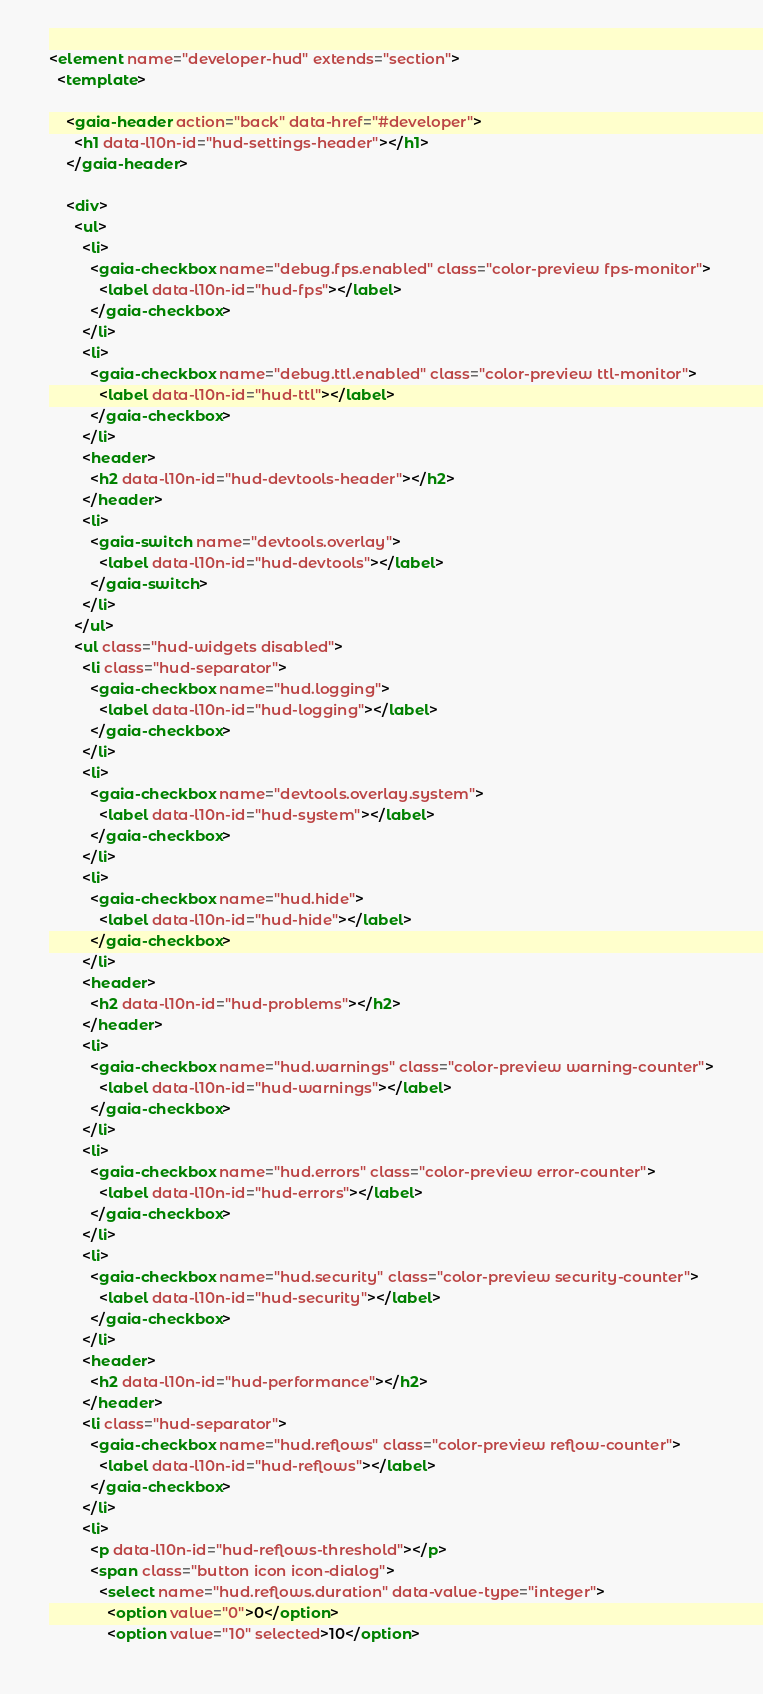<code> <loc_0><loc_0><loc_500><loc_500><_HTML_><element name="developer-hud" extends="section">
  <template>

    <gaia-header action="back" data-href="#developer">
      <h1 data-l10n-id="hud-settings-header"></h1>
    </gaia-header>

    <div>
      <ul>
        <li>
          <gaia-checkbox name="debug.fps.enabled" class="color-preview fps-monitor">
            <label data-l10n-id="hud-fps"></label>
          </gaia-checkbox>
        </li>
        <li>
          <gaia-checkbox name="debug.ttl.enabled" class="color-preview ttl-monitor">
            <label data-l10n-id="hud-ttl"></label>
          </gaia-checkbox>
        </li>
        <header>
          <h2 data-l10n-id="hud-devtools-header"></h2>
        </header>
        <li>
          <gaia-switch name="devtools.overlay">
            <label data-l10n-id="hud-devtools"></label>
          </gaia-switch>
        </li>
      </ul>
      <ul class="hud-widgets disabled">
        <li class="hud-separator">
          <gaia-checkbox name="hud.logging">
            <label data-l10n-id="hud-logging"></label>
          </gaia-checkbox>
        </li>
        <li>
          <gaia-checkbox name="devtools.overlay.system">
            <label data-l10n-id="hud-system"></label>
          </gaia-checkbox>
        </li>
        <li>
          <gaia-checkbox name="hud.hide">
            <label data-l10n-id="hud-hide"></label>
          </gaia-checkbox>
        </li>
        <header>
          <h2 data-l10n-id="hud-problems"></h2>
        </header>
        <li>
          <gaia-checkbox name="hud.warnings" class="color-preview warning-counter">
            <label data-l10n-id="hud-warnings"></label>
          </gaia-checkbox>
        </li>
        <li>
          <gaia-checkbox name="hud.errors" class="color-preview error-counter">
            <label data-l10n-id="hud-errors"></label>
          </gaia-checkbox>
        </li>
        <li>
          <gaia-checkbox name="hud.security" class="color-preview security-counter">
            <label data-l10n-id="hud-security"></label>
          </gaia-checkbox>
        </li>
        <header>
          <h2 data-l10n-id="hud-performance"></h2>
        </header>
        <li class="hud-separator">
          <gaia-checkbox name="hud.reflows" class="color-preview reflow-counter">
            <label data-l10n-id="hud-reflows"></label>
          </gaia-checkbox>
        </li>
        <li>
          <p data-l10n-id="hud-reflows-threshold"></p>
          <span class="button icon icon-dialog">
            <select name="hud.reflows.duration" data-value-type="integer">
              <option value="0">0</option>
              <option value="10" selected>10</option></code> 